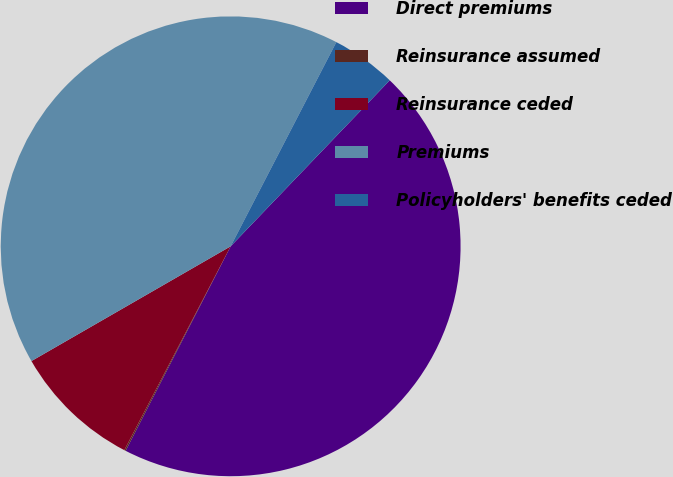Convert chart. <chart><loc_0><loc_0><loc_500><loc_500><pie_chart><fcel>Direct premiums<fcel>Reinsurance assumed<fcel>Reinsurance ceded<fcel>Premiums<fcel>Policyholders' benefits ceded<nl><fcel>45.39%<fcel>0.1%<fcel>9.03%<fcel>40.92%<fcel>4.56%<nl></chart> 